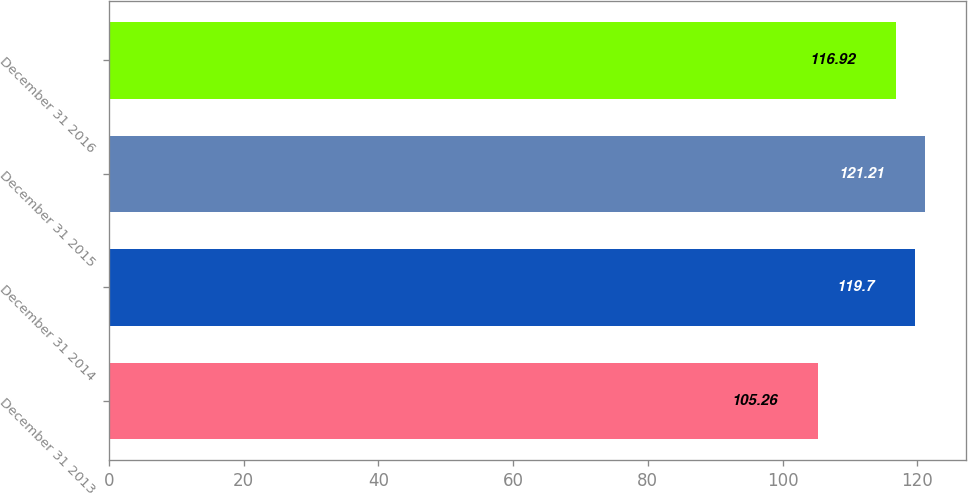Convert chart. <chart><loc_0><loc_0><loc_500><loc_500><bar_chart><fcel>December 31 2013<fcel>December 31 2014<fcel>December 31 2015<fcel>December 31 2016<nl><fcel>105.26<fcel>119.7<fcel>121.21<fcel>116.92<nl></chart> 